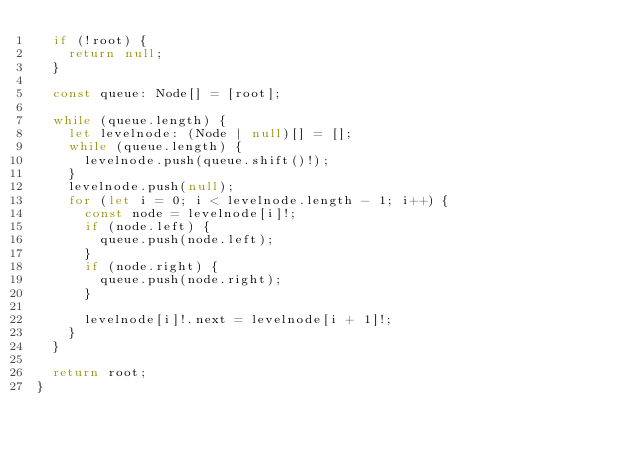Convert code to text. <code><loc_0><loc_0><loc_500><loc_500><_TypeScript_>  if (!root) {
    return null;
  }

  const queue: Node[] = [root];

  while (queue.length) {
    let levelnode: (Node | null)[] = [];
    while (queue.length) {
      levelnode.push(queue.shift()!);
    }
    levelnode.push(null);
    for (let i = 0; i < levelnode.length - 1; i++) {
      const node = levelnode[i]!;
      if (node.left) {
        queue.push(node.left);
      }
      if (node.right) {
        queue.push(node.right);
      }

      levelnode[i]!.next = levelnode[i + 1]!;
    }
  }

  return root;
}
</code> 